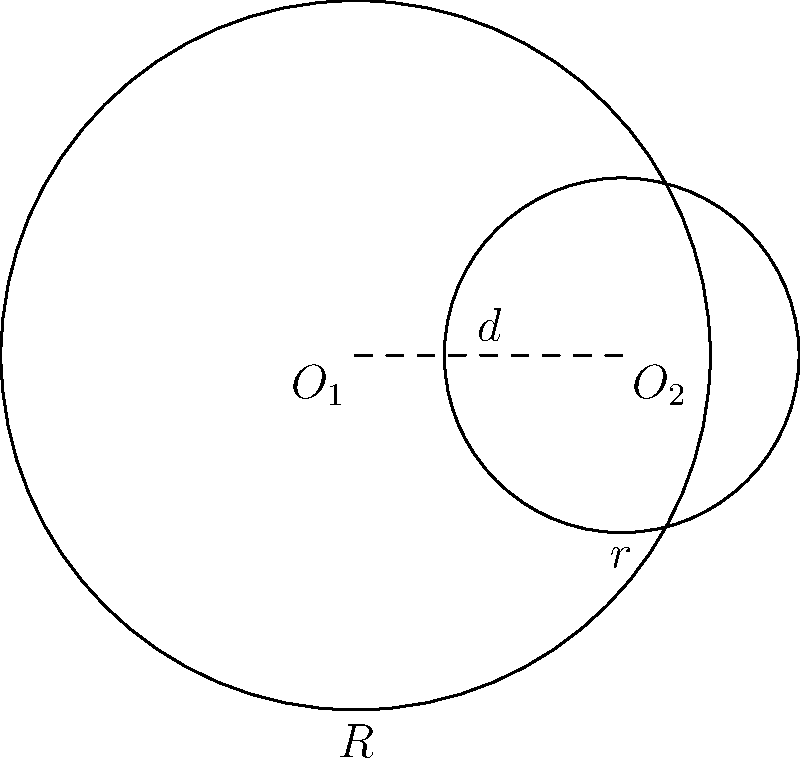As a proud student of Punjab University, you're tasked with calculating the area of a crescent moon shape formed by two overlapping circles. The larger circle has a radius $R = 2$ cm, and the smaller circle has a radius $r = 1$ cm. The distance between their centers is $d = 1.5$ cm. Calculate the area of the crescent moon shape to the nearest 0.01 cm². Let's approach this step-by-step:

1) First, we need to calculate the area of the larger circle:
   $$A_1 = \pi R^2 = \pi (2)^2 = 4\pi \text{ cm}^2$$

2) Next, calculate the area of the smaller circle:
   $$A_2 = \pi r^2 = \pi (1)^2 = \pi \text{ cm}^2$$

3) Now, we need to find the area of overlap between the two circles. For this, we'll use the formula for the area of intersection of two circles:

   $$A_{overlap} = R^2 \arccos(\frac{d}{2R}) + r^2 \arccos(\frac{d}{2r}) - \frac{1}{2}\sqrt{(-d+r+R)(d+r-R)(d-r+R)(d+r+R)}$$

4) Substituting the values:
   $$A_{overlap} = 2^2 \arccos(\frac{1.5}{2(2)}) + 1^2 \arccos(\frac{1.5}{2(1)}) - \frac{1}{2}\sqrt{(-1.5+1+2)(1.5+1-2)(1.5-1+2)(1.5+1+2)}$$

5) Simplifying:
   $$A_{overlap} = 4 \arccos(0.375) + \arccos(0.75) - \frac{1}{2}\sqrt{1.5 \cdot 0.5 \cdot 2.5 \cdot 4.5}$$

6) Calculate this value (you can use a calculator):
   $$A_{overlap} \approx 0.7813 \text{ cm}^2$$

7) The area of the crescent moon is the area of the larger circle minus the area of overlap:
   $$A_{crescent} = A_1 - A_{overlap} = 4\pi - 0.7813 \approx 11.7851 \text{ cm}^2$$

8) Rounding to the nearest 0.01:
   $$A_{crescent} \approx 11.79 \text{ cm}^2$$
Answer: 11.79 cm² 